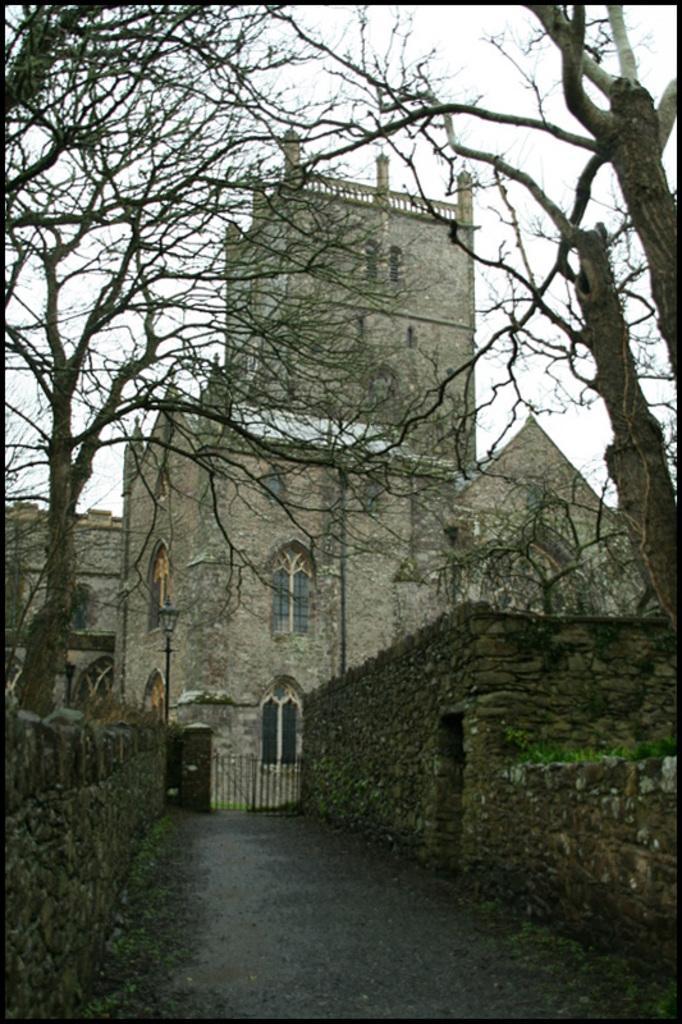Describe this image in one or two sentences. In this image I can see many dried trees. In the background I can see the fort and there are windows to it. I can also see the white color sky in the back. 